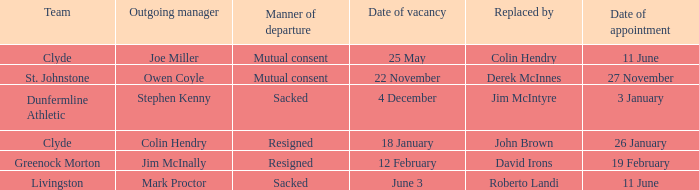I want to know the team that was sacked and date of vacancy was 4 december Dunfermline Athletic. 